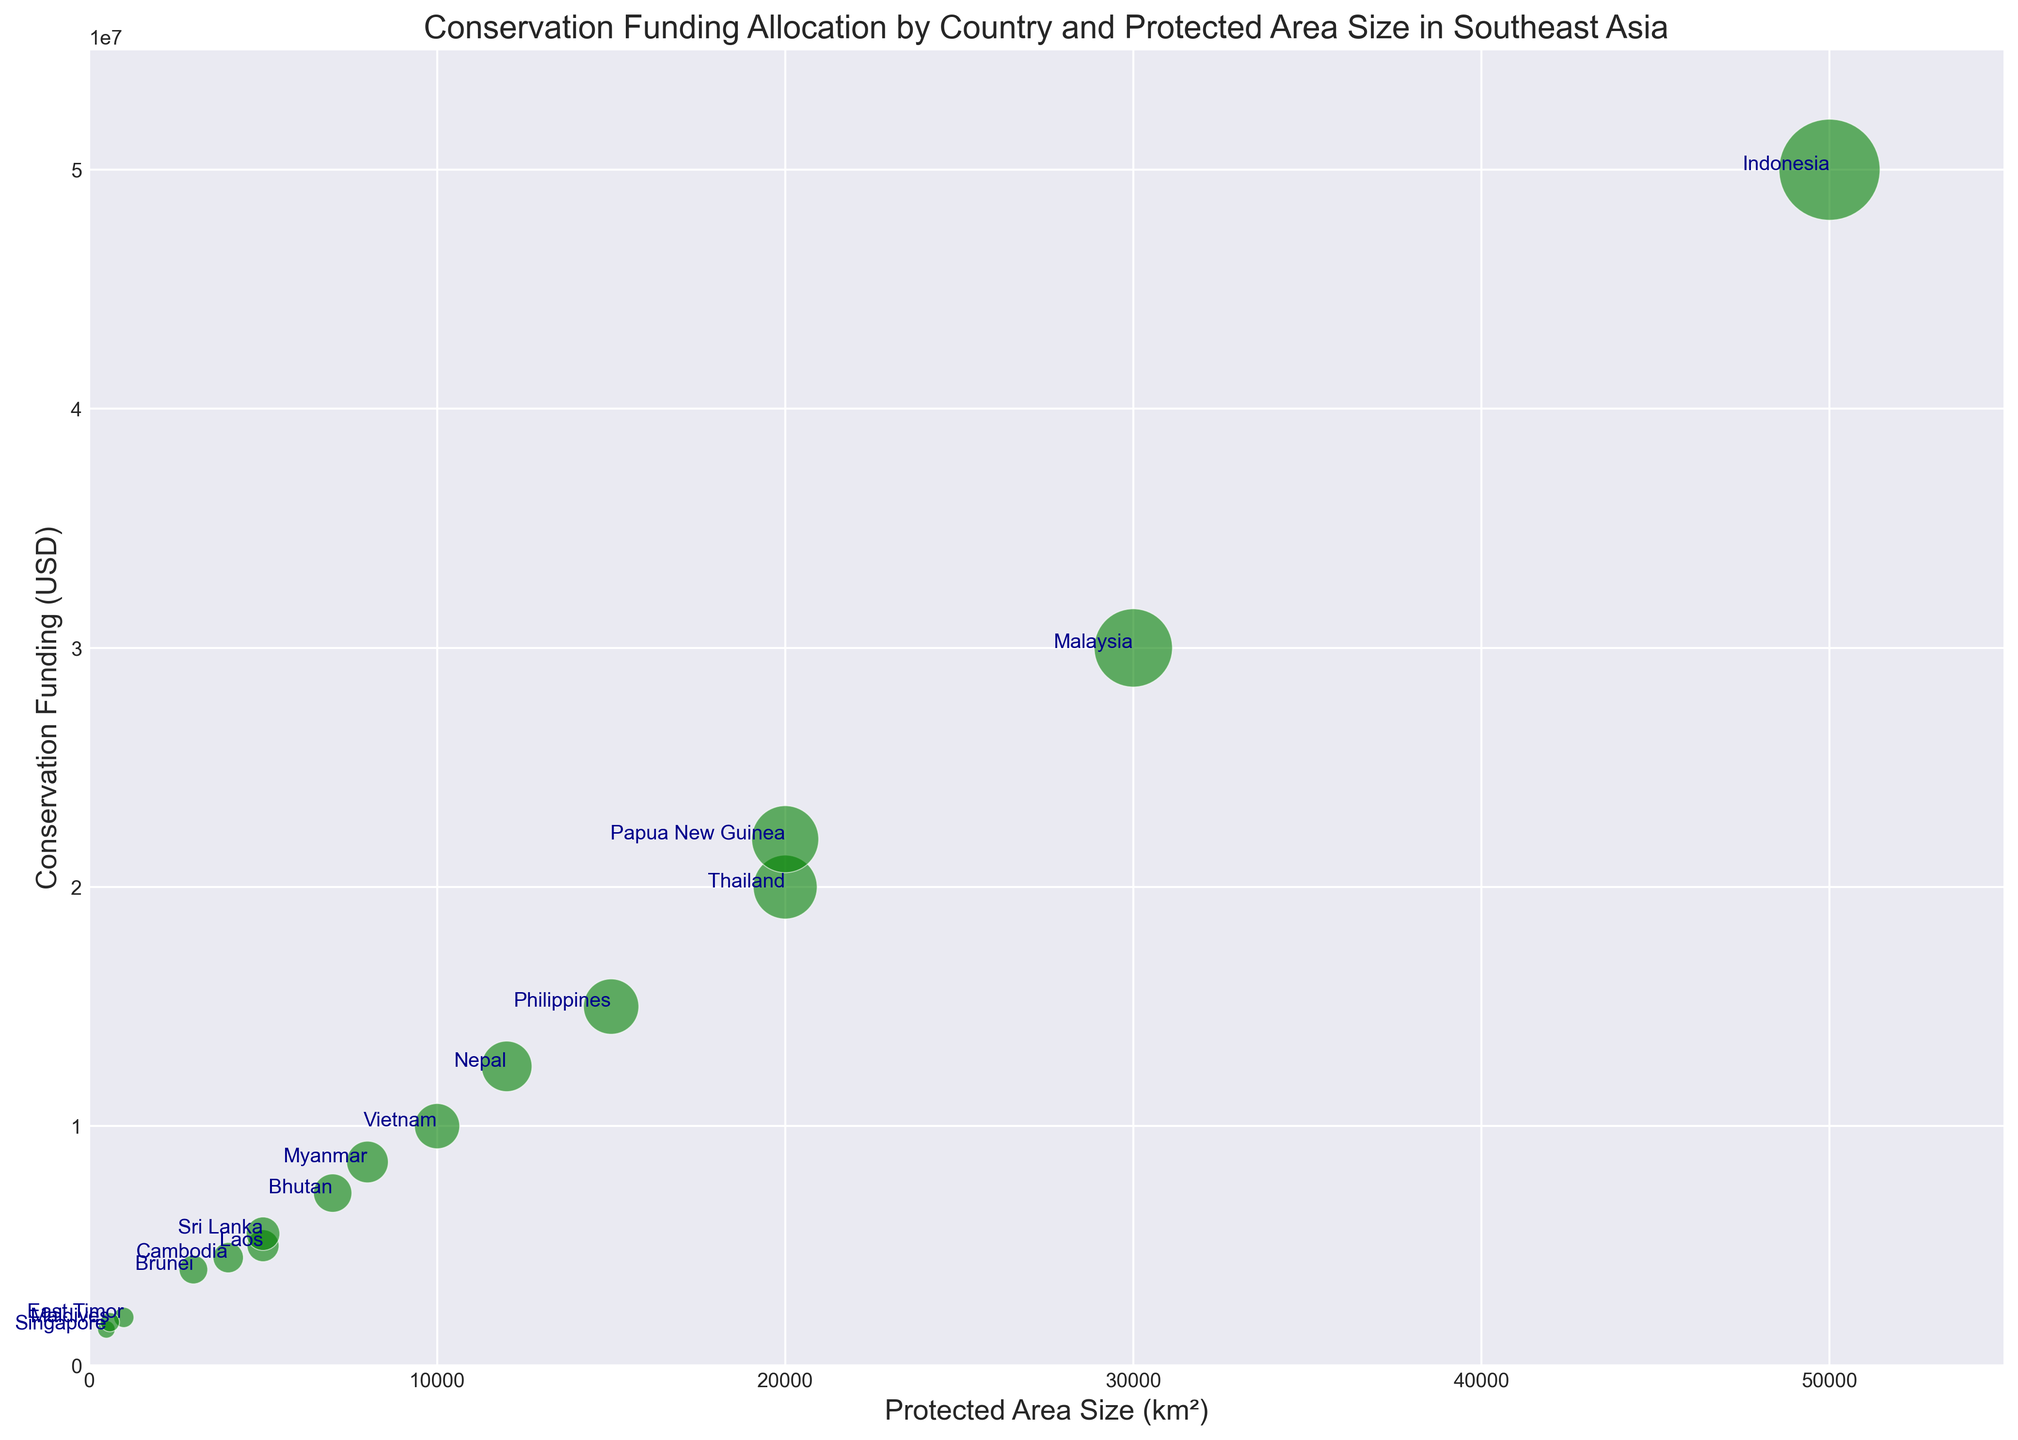What is the country with the largest protected area size? Locate the bubble corresponding to the largest value on the x-axis (Protected Area Size). The country label closer to the farthest right is the one with the largest protected area size.
Answer: Indonesia Which country receives the highest conservation funding? Identify the bubble that is highest on the y-axis (Conservation Funding). The country label nearest to the top is the one with the highest conservation funding.
Answer: Indonesia Which country has the smallest protected area size and how much funding does it receive? Find the bubble closest to the origin on the x-axis (Protected Area Size) and then move to see the y-axis value representing its Conservation Funding.
Answer: Singapore, $1.5M Compare the conservation funding between Myanmar and Cambodia. Which country has higher funding? Locate the bubbles labeled "Myanmar" and "Cambodia". Myanmar's bubble is higher up on the y-axis than Cambodia's bubble, indicating higher conservation funding.
Answer: Myanmar What is the difference in conservation funding between Malaysia and Thailand? Locate Malaysia and Thailand bubbles, note their y-axis positions. Malaysia is at $30M and Thailand at $20M. The difference is $30M - $20M = $10M.
Answer: $10M Which three countries receive the least conservation funding? Identify the three lowest bubbles on the y-axis and note their country labels.
Answer: Singapore, Maldives, East Timor What is the average protected area size of countries with conservation funding over $10M? Identify bubbles with y-axis values above $10M: Indonesia, Malaysia, Thailand, Philippines, Vietnam, Papua New Guinea, Bhutan, Nepal. Calculate their x-axis averages: (50000 + 30000 + 20000 + 15000 + 10000 + 20000 + 7000 + 12000) / 8 = 20500 km².
Answer: 20500 km² Which countries have a protected area size of over 10,000 km² and receive less than $15M in funding? Identify the bubbles where x-axis values are over 10,000 km² and y-axis values are under $15M: Myanmar (8000, $8.5M), Nepal (12000, $12.5M).
Answer: Nepal How does the conservation funding of Brunei compare to Laos? Find the positions of Brunei and Laos' bubbles on the y-axis. Brunei is at $4M and Laos is at $5M. Brunei receives $1M less than Laos.
Answer: Laos Which country has the smallest protected area size but has more funding than at least five other countries? Identify the bubble closest to the origin on the x-axis but higher on the y-axis than at least five other bubbles. Singapore has the smallest area 500 km² and receives $1.5M, more than five other countries.
Answer: Singapore 